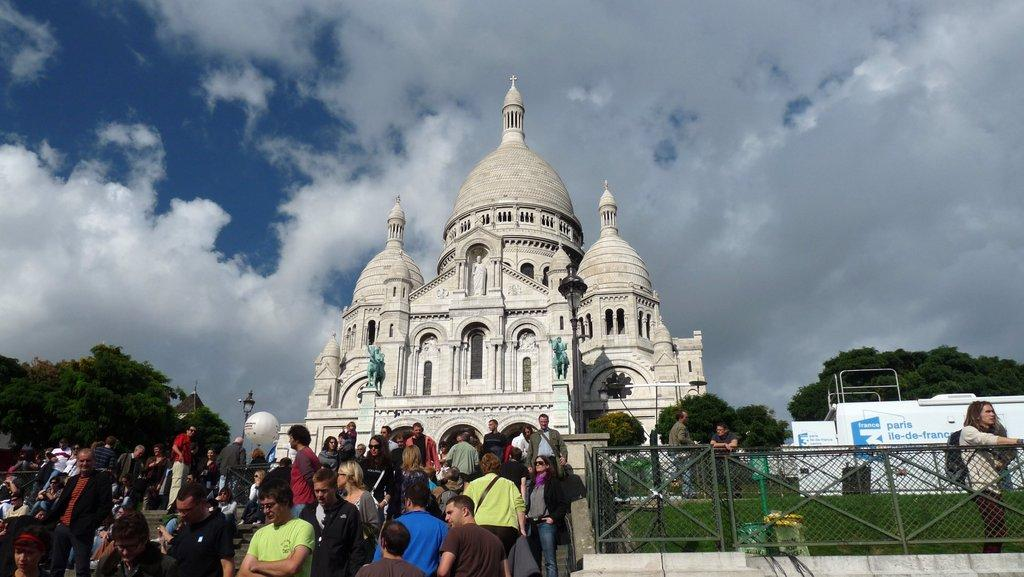What is the main structure in the middle of the image? There is a building in the middle of the image. Who or what can be seen at the bottom of the image? There are persons at the bottom of the image. What type of vegetation is present in the middle of the image? There are trees in the middle of the image. What is visible at the top of the image? The sky is visible at the top of the image. Can you see a cactus growing in the building in the image? There is no cactus present in the image. 